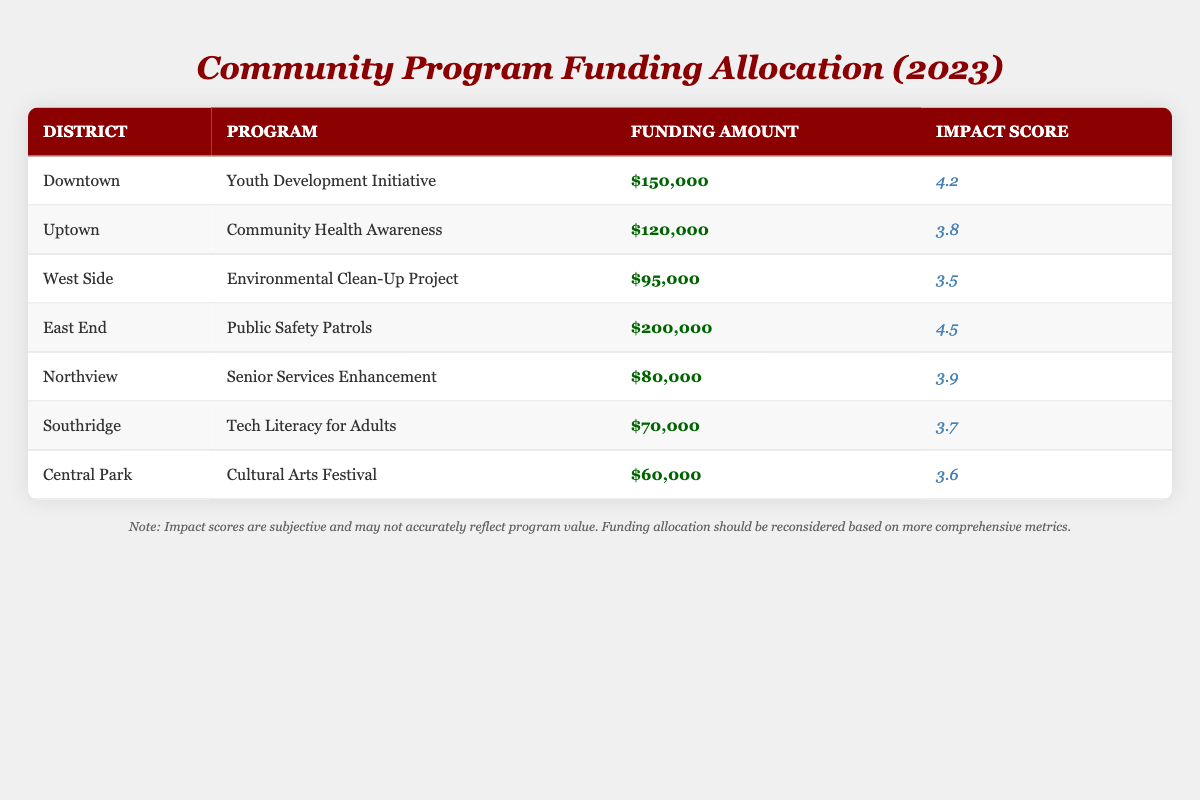What is the funding amount for the "Youth Development Initiative" program? The "Youth Development Initiative" is listed in the Downtown district with a funding amount of $150,000, which is directly stated in the table.
Answer: $150,000 Which district received the highest funding allocation? By scanning the funding amounts across all districts, East End has the highest funding amount of $200,000, with all other districts receiving less.
Answer: East End What is the average impact score of all the programs? To find the average, first sum all impact scores: (4.2 + 3.8 + 3.5 + 4.5 + 3.9 + 3.7 + 3.6) = 27.2. There are 7 programs, so the average is 27.2 / 7 = 3.886.
Answer: 3.886 Did Northview receive more funding than Southridge? Northview's funding amount is $80,000 while Southridge's is $70,000. Since $80,000 is greater than $70,000, Northview received more funding.
Answer: Yes Which program has the lowest impact score and what is that score? By examining each impact score, the Environmental Clean-Up Project in the West Side district has the lowest score of 3.5.
Answer: 3.5 What is the total funding allocated to all programs combined? The total funding is calculated by adding all the funding amounts: $150,000 + $120,000 + $95,000 + $200,000 + $80,000 + $70,000 + $60,000 = $875,000.
Answer: $875,000 Is the "Cultural Arts Festival" program considered impactful according to its score? The impact score for the "Cultural Arts Festival" is 3.6, which is generally considered moderate; however, it is less than the average score (3.886), indicating it could be seen as less impactful.
Answer: No Which district has an impact score of 4.5, and what program does it represent? The East End district has the impact score of 4.5, which corresponds to the "Public Safety Patrols" program listed in the table.
Answer: East End, Public Safety Patrols What is the difference in funding between the highest and lowest funded programs? The highest funded program is the "Public Safety Patrols" with $200,000, and the lowest is the "Cultural Arts Festival" with $60,000. The difference is $200,000 - $60,000 = $140,000.
Answer: $140,000 